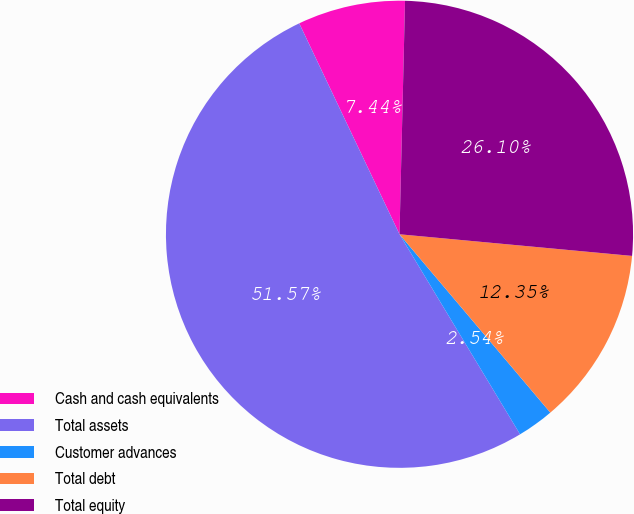Convert chart to OTSL. <chart><loc_0><loc_0><loc_500><loc_500><pie_chart><fcel>Cash and cash equivalents<fcel>Total assets<fcel>Customer advances<fcel>Total debt<fcel>Total equity<nl><fcel>7.44%<fcel>51.57%<fcel>2.54%<fcel>12.35%<fcel>26.1%<nl></chart> 